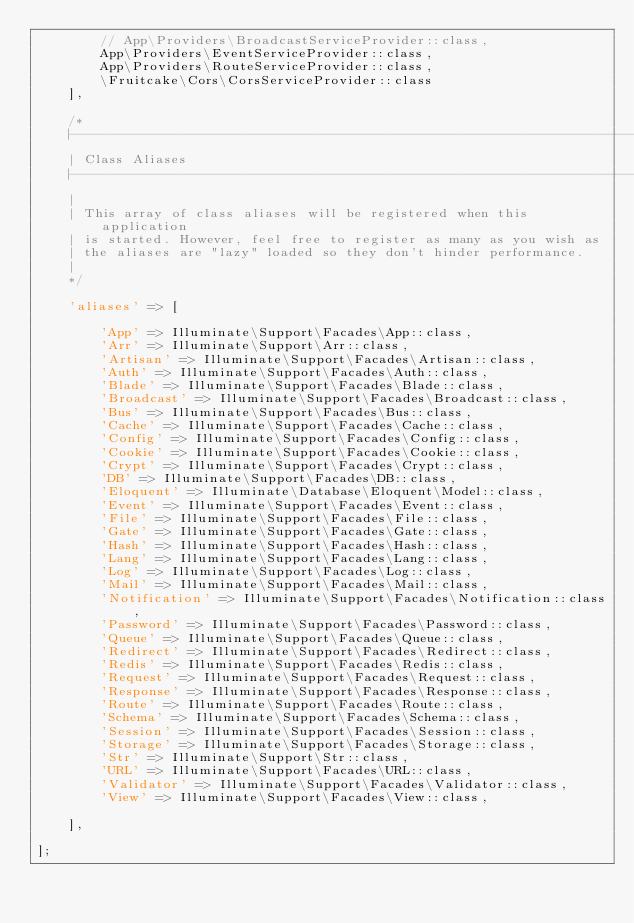Convert code to text. <code><loc_0><loc_0><loc_500><loc_500><_PHP_>        // App\Providers\BroadcastServiceProvider::class,
        App\Providers\EventServiceProvider::class,
        App\Providers\RouteServiceProvider::class,
        \Fruitcake\Cors\CorsServiceProvider::class
    ],

    /*
    |--------------------------------------------------------------------------
    | Class Aliases
    |--------------------------------------------------------------------------
    |
    | This array of class aliases will be registered when this application
    | is started. However, feel free to register as many as you wish as
    | the aliases are "lazy" loaded so they don't hinder performance.
    |
    */

    'aliases' => [

        'App' => Illuminate\Support\Facades\App::class,
        'Arr' => Illuminate\Support\Arr::class,
        'Artisan' => Illuminate\Support\Facades\Artisan::class,
        'Auth' => Illuminate\Support\Facades\Auth::class,
        'Blade' => Illuminate\Support\Facades\Blade::class,
        'Broadcast' => Illuminate\Support\Facades\Broadcast::class,
        'Bus' => Illuminate\Support\Facades\Bus::class,
        'Cache' => Illuminate\Support\Facades\Cache::class,
        'Config' => Illuminate\Support\Facades\Config::class,
        'Cookie' => Illuminate\Support\Facades\Cookie::class,
        'Crypt' => Illuminate\Support\Facades\Crypt::class,
        'DB' => Illuminate\Support\Facades\DB::class,
        'Eloquent' => Illuminate\Database\Eloquent\Model::class,
        'Event' => Illuminate\Support\Facades\Event::class,
        'File' => Illuminate\Support\Facades\File::class,
        'Gate' => Illuminate\Support\Facades\Gate::class,
        'Hash' => Illuminate\Support\Facades\Hash::class,
        'Lang' => Illuminate\Support\Facades\Lang::class,
        'Log' => Illuminate\Support\Facades\Log::class,
        'Mail' => Illuminate\Support\Facades\Mail::class,
        'Notification' => Illuminate\Support\Facades\Notification::class,
        'Password' => Illuminate\Support\Facades\Password::class,
        'Queue' => Illuminate\Support\Facades\Queue::class,
        'Redirect' => Illuminate\Support\Facades\Redirect::class,
        'Redis' => Illuminate\Support\Facades\Redis::class,
        'Request' => Illuminate\Support\Facades\Request::class,
        'Response' => Illuminate\Support\Facades\Response::class,
        'Route' => Illuminate\Support\Facades\Route::class,
        'Schema' => Illuminate\Support\Facades\Schema::class,
        'Session' => Illuminate\Support\Facades\Session::class,
        'Storage' => Illuminate\Support\Facades\Storage::class,
        'Str' => Illuminate\Support\Str::class,
        'URL' => Illuminate\Support\Facades\URL::class,
        'Validator' => Illuminate\Support\Facades\Validator::class,
        'View' => Illuminate\Support\Facades\View::class,

    ],

];
</code> 